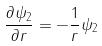<formula> <loc_0><loc_0><loc_500><loc_500>\frac { \partial \psi _ { 2 } } { \partial r } = - \frac { 1 } { r } \psi _ { 2 }</formula> 